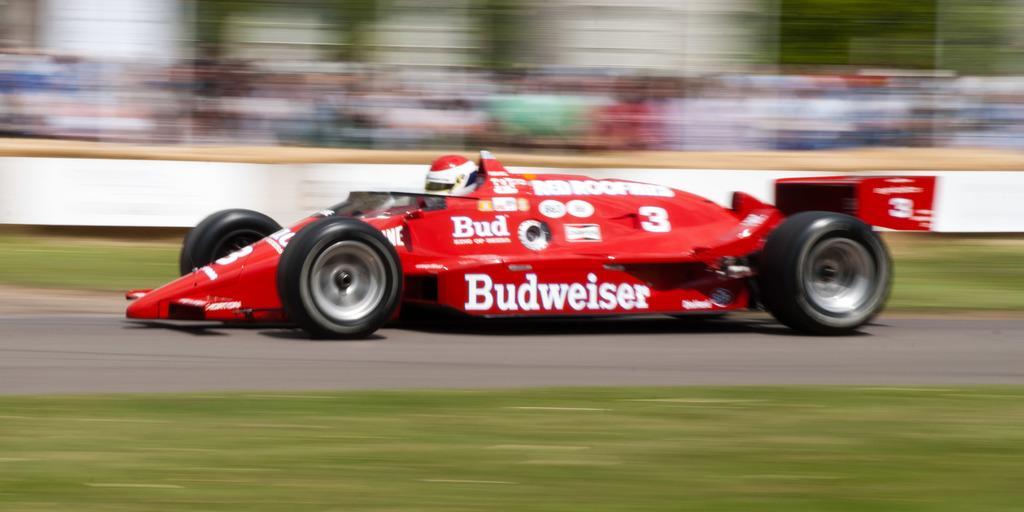How would you summarize this image in a sentence or two? In this image in the center there is a vehicle, at the bottom there is walkway and grass and there is blurry background. 